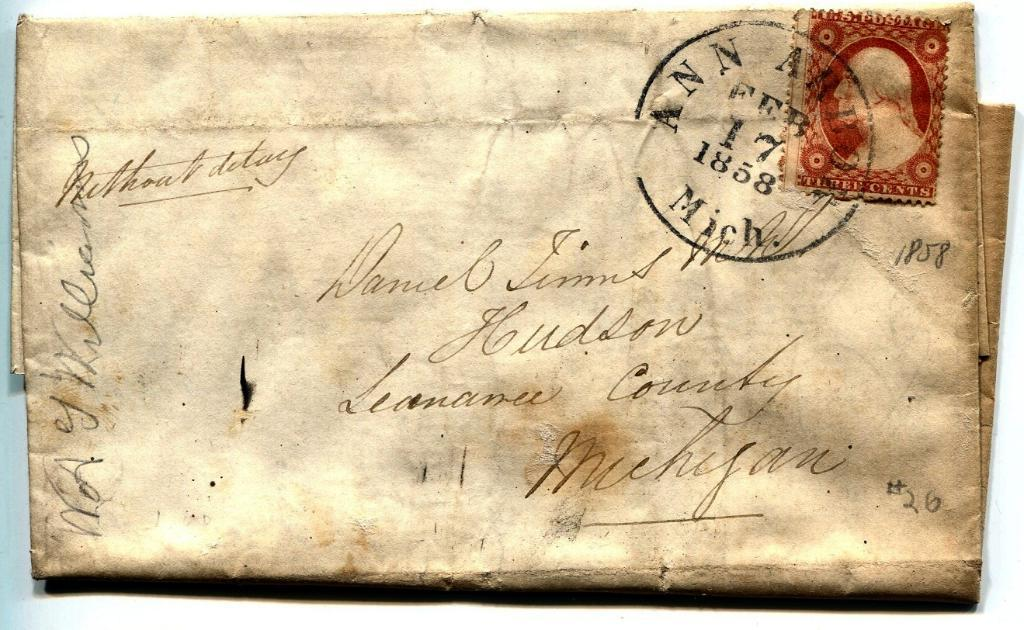What type of paper is present in the image? The image contains a postal paper. What can be found on the postal paper? There are texts and postage stamps on the postal paper. What type of hammer is used to secure the postal paper in the image? There is no hammer present in the image, and the postal paper is not secured in any way. 